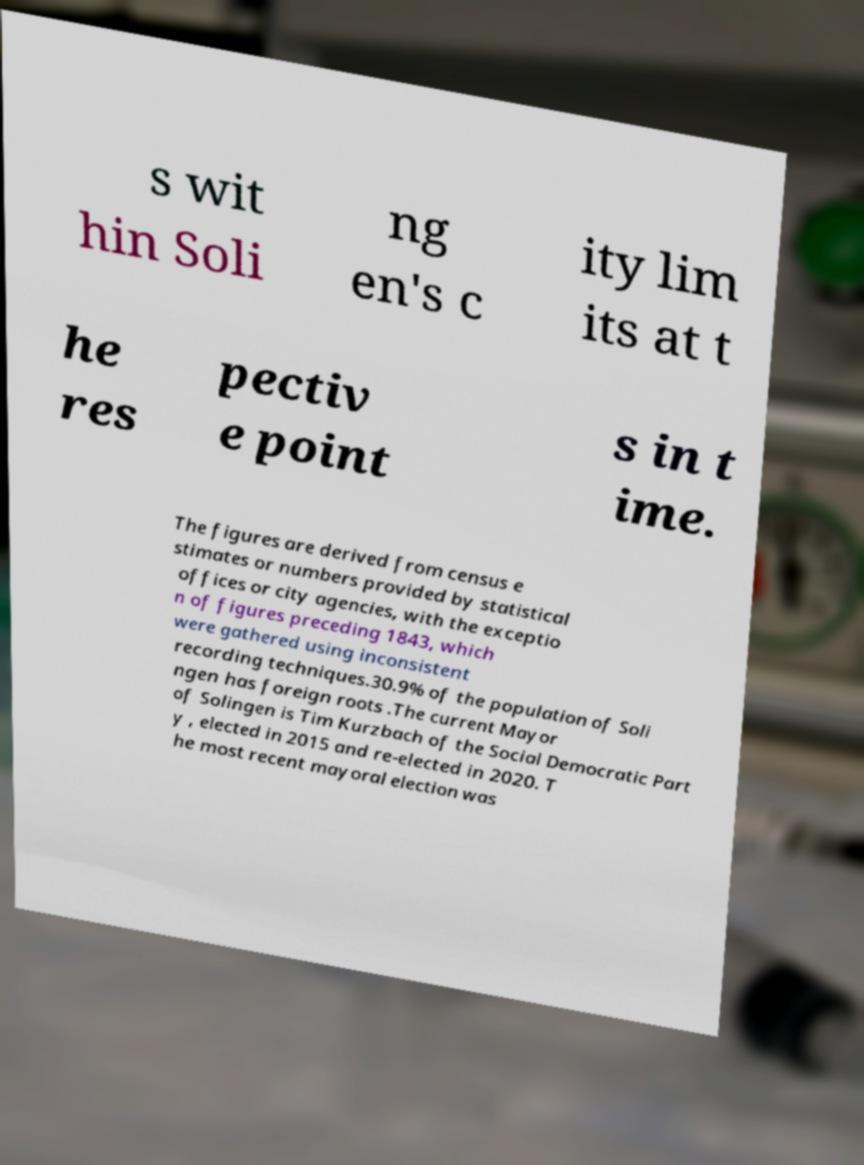Can you read and provide the text displayed in the image?This photo seems to have some interesting text. Can you extract and type it out for me? s wit hin Soli ng en's c ity lim its at t he res pectiv e point s in t ime. The figures are derived from census e stimates or numbers provided by statistical offices or city agencies, with the exceptio n of figures preceding 1843, which were gathered using inconsistent recording techniques.30.9% of the population of Soli ngen has foreign roots .The current Mayor of Solingen is Tim Kurzbach of the Social Democratic Part y , elected in 2015 and re-elected in 2020. T he most recent mayoral election was 